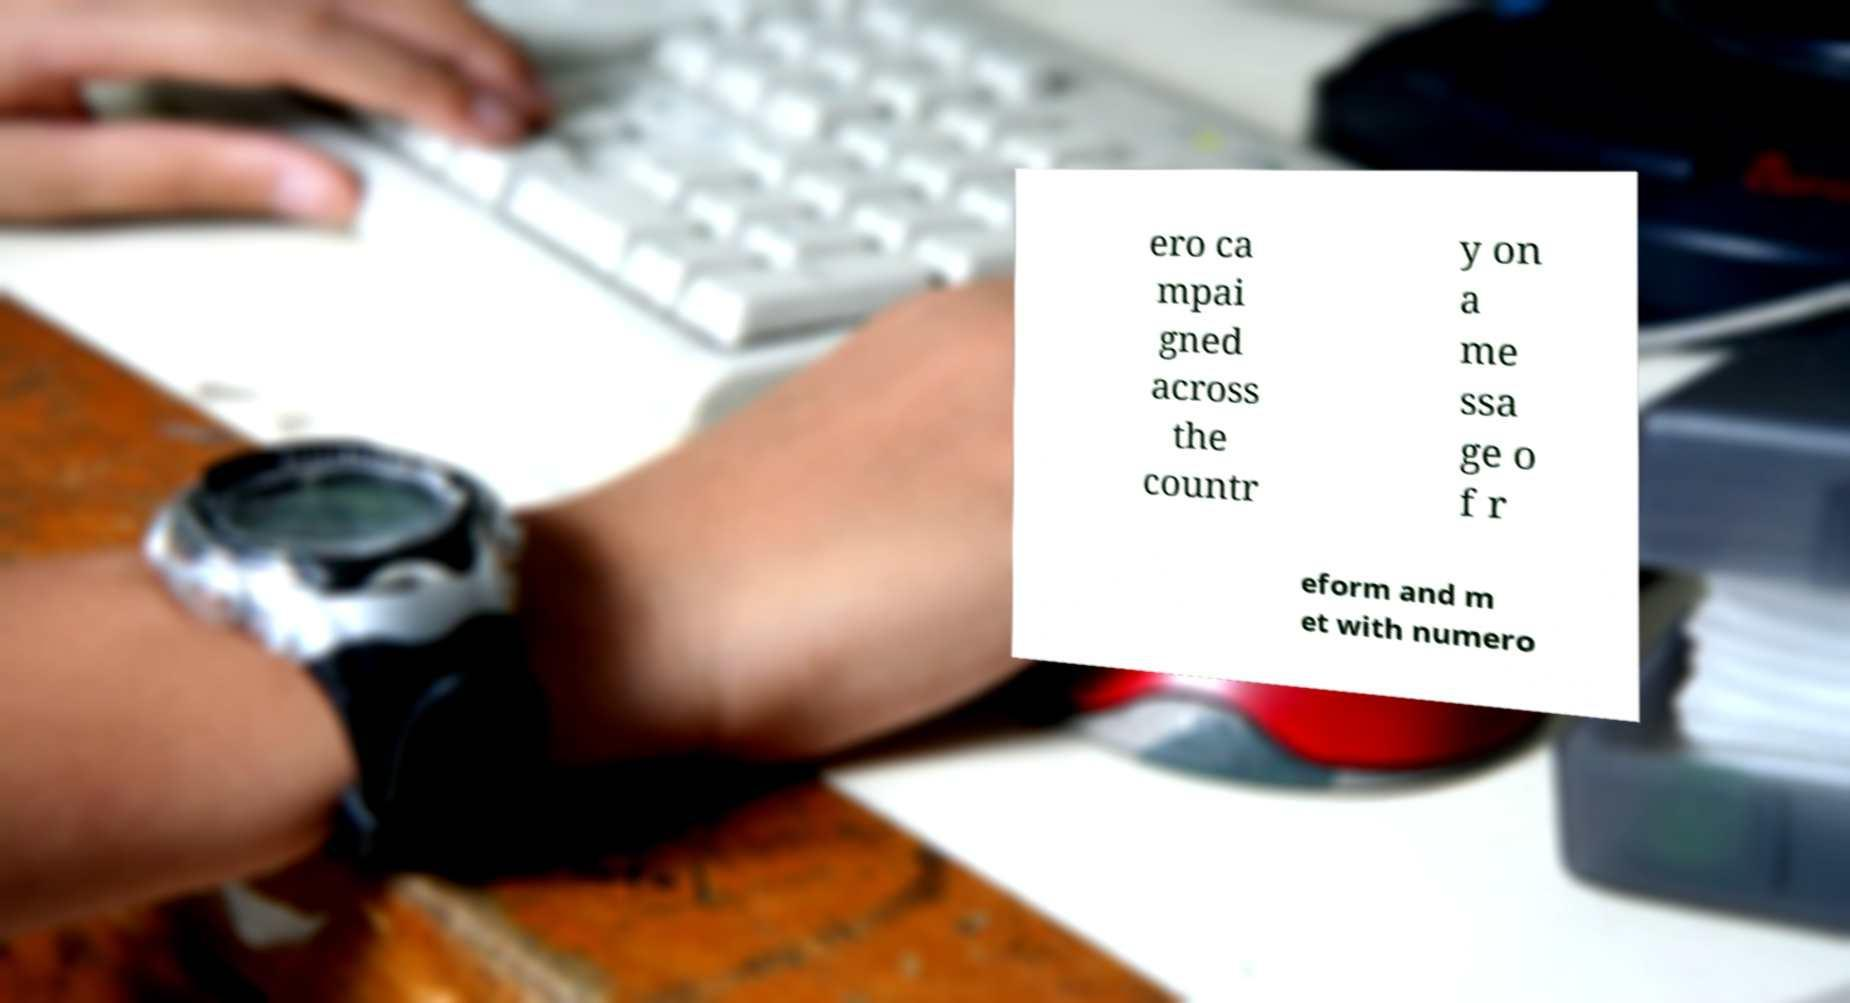Can you accurately transcribe the text from the provided image for me? ero ca mpai gned across the countr y on a me ssa ge o f r eform and m et with numero 